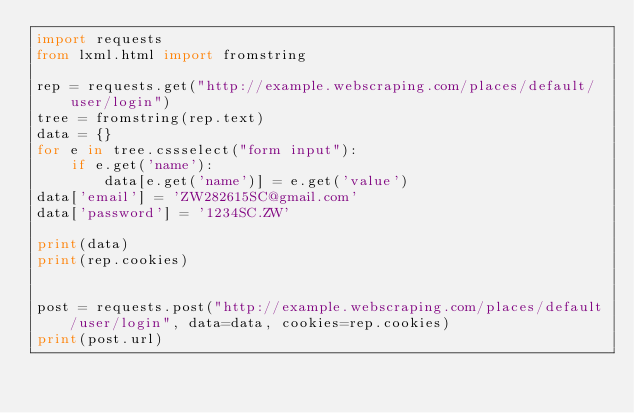Convert code to text. <code><loc_0><loc_0><loc_500><loc_500><_Python_>import requests
from lxml.html import fromstring

rep = requests.get("http://example.webscraping.com/places/default/user/login")
tree = fromstring(rep.text)
data = {}
for e in tree.cssselect("form input"):
    if e.get('name'):
        data[e.get('name')] = e.get('value')
data['email'] = 'ZW282615SC@gmail.com'
data['password'] = '1234SC.ZW'

print(data)
print(rep.cookies)


post = requests.post("http://example.webscraping.com/places/default/user/login", data=data, cookies=rep.cookies)
print(post.url)
</code> 